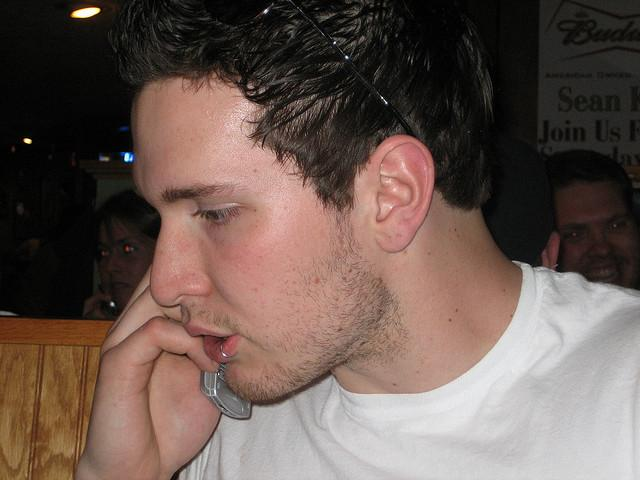What color is the cell phone which the man talks on? silver 